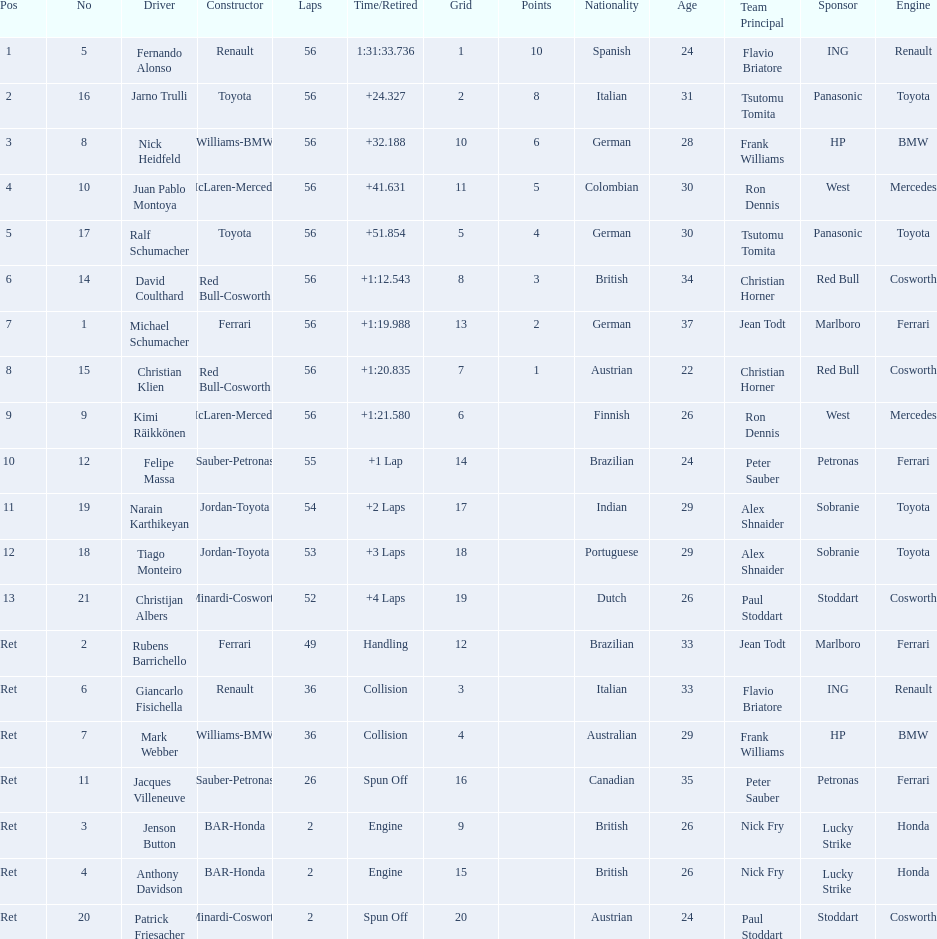What place did fernando alonso finish? 1. How long did it take alonso to finish the race? 1:31:33.736. 